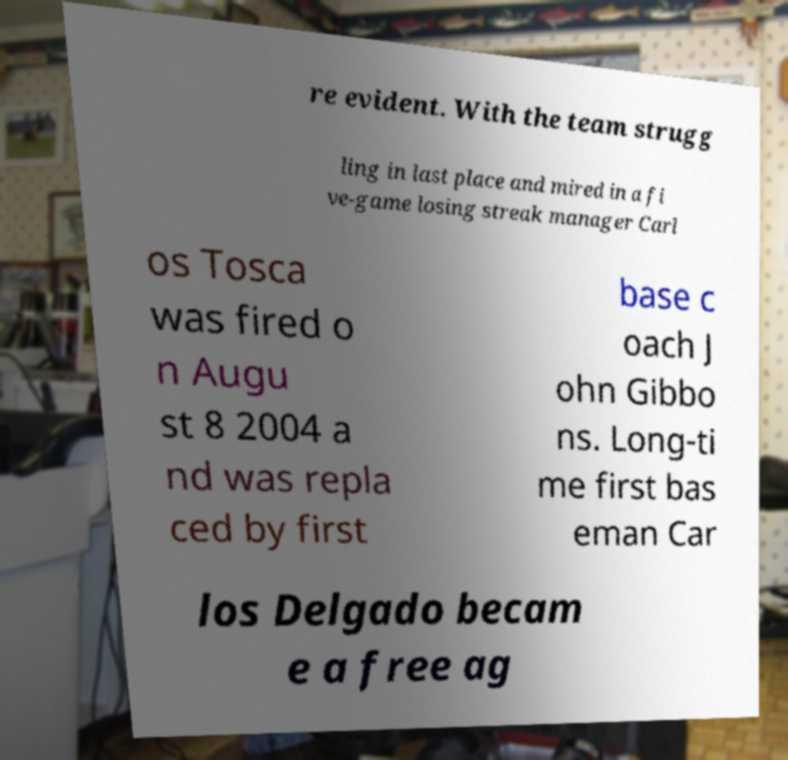What messages or text are displayed in this image? I need them in a readable, typed format. re evident. With the team strugg ling in last place and mired in a fi ve-game losing streak manager Carl os Tosca was fired o n Augu st 8 2004 a nd was repla ced by first base c oach J ohn Gibbo ns. Long-ti me first bas eman Car los Delgado becam e a free ag 